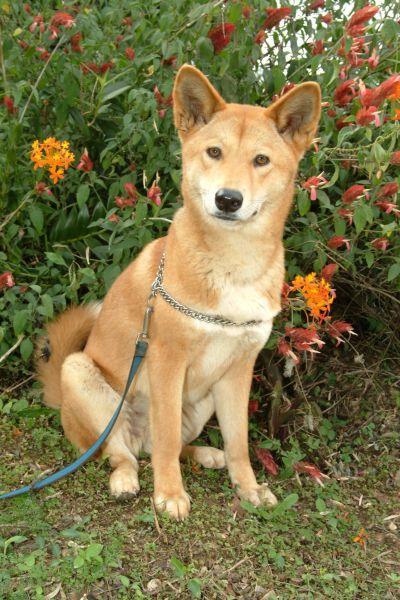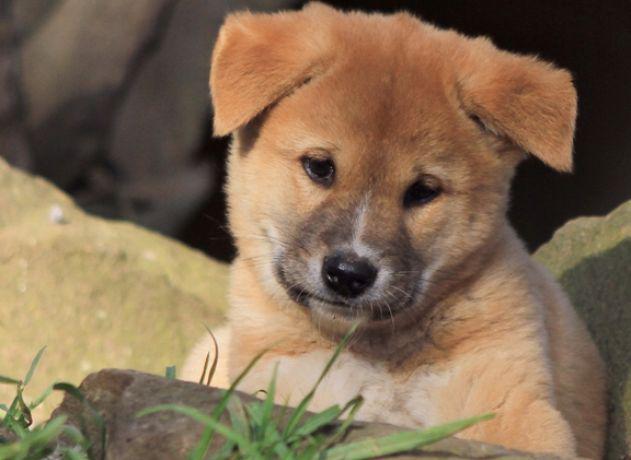The first image is the image on the left, the second image is the image on the right. Examine the images to the left and right. Is the description "There are three dogs" accurate? Answer yes or no. No. 